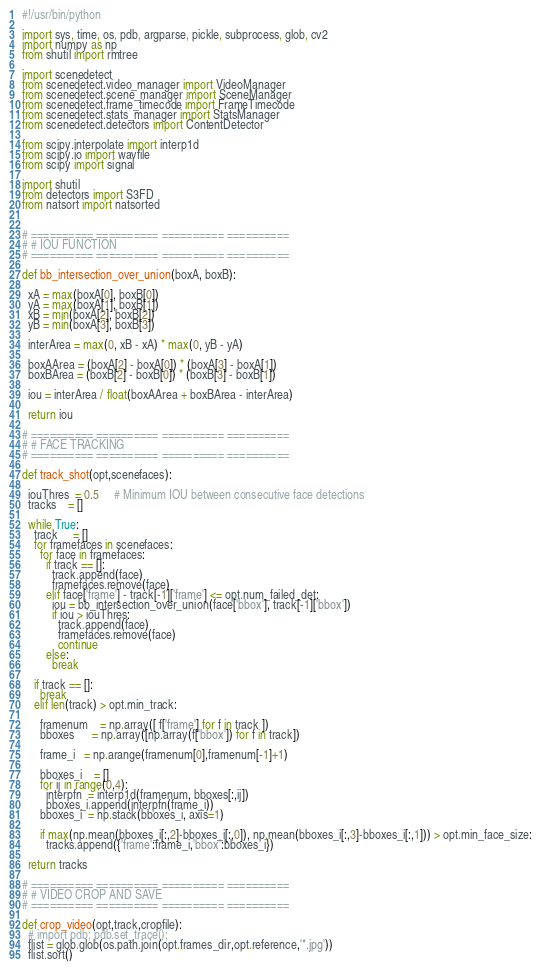Convert code to text. <code><loc_0><loc_0><loc_500><loc_500><_Python_>#!/usr/bin/python

import sys, time, os, pdb, argparse, pickle, subprocess, glob, cv2
import numpy as np
from shutil import rmtree

import scenedetect
from scenedetect.video_manager import VideoManager
from scenedetect.scene_manager import SceneManager
from scenedetect.frame_timecode import FrameTimecode
from scenedetect.stats_manager import StatsManager
from scenedetect.detectors import ContentDetector

from scipy.interpolate import interp1d
from scipy.io import wavfile
from scipy import signal

import shutil
from detectors import S3FD
from natsort import natsorted


# ========== ========== ========== ==========
# # IOU FUNCTION
# ========== ========== ========== ==========

def bb_intersection_over_union(boxA, boxB):
  
  xA = max(boxA[0], boxB[0])
  yA = max(boxA[1], boxB[1])
  xB = min(boxA[2], boxB[2])
  yB = min(boxA[3], boxB[3])
 
  interArea = max(0, xB - xA) * max(0, yB - yA)
 
  boxAArea = (boxA[2] - boxA[0]) * (boxA[3] - boxA[1])
  boxBArea = (boxB[2] - boxB[0]) * (boxB[3] - boxB[1])
 
  iou = interArea / float(boxAArea + boxBArea - interArea)
 
  return iou

# ========== ========== ========== ==========
# # FACE TRACKING
# ========== ========== ========== ==========

def track_shot(opt,scenefaces):

  iouThres  = 0.5     # Minimum IOU between consecutive face detections
  tracks    = []

  while True:
    track     = []
    for framefaces in scenefaces:
      for face in framefaces:
        if track == []:
          track.append(face)
          framefaces.remove(face)
        elif face['frame'] - track[-1]['frame'] <= opt.num_failed_det:
          iou = bb_intersection_over_union(face['bbox'], track[-1]['bbox'])
          if iou > iouThres:
            track.append(face)
            framefaces.remove(face)
            continue
        else:
          break

    if track == []:
      break
    elif len(track) > opt.min_track:
      
      framenum    = np.array([ f['frame'] for f in track ])
      bboxes      = np.array([np.array(f['bbox']) for f in track])

      frame_i   = np.arange(framenum[0],framenum[-1]+1)

      bboxes_i    = []
      for ij in range(0,4):
        interpfn  = interp1d(framenum, bboxes[:,ij])
        bboxes_i.append(interpfn(frame_i))
      bboxes_i  = np.stack(bboxes_i, axis=1)

      if max(np.mean(bboxes_i[:,2]-bboxes_i[:,0]), np.mean(bboxes_i[:,3]-bboxes_i[:,1])) > opt.min_face_size:
        tracks.append({'frame':frame_i,'bbox':bboxes_i})

  return tracks

# ========== ========== ========== ==========
# # VIDEO CROP AND SAVE
# ========== ========== ========== ==========
        
def crop_video(opt,track,cropfile):
  # import pdb; pdb.set_trace();
  flist = glob.glob(os.path.join(opt.frames_dir,opt.reference,'*.jpg'))
  flist.sort()
</code> 